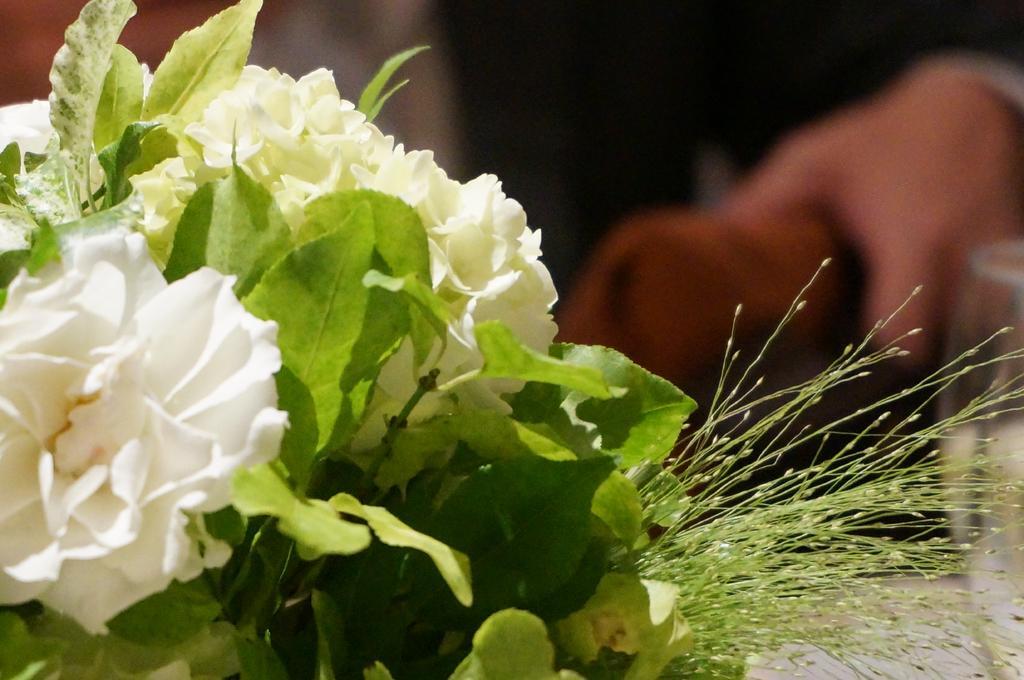How would you summarize this image in a sentence or two? In this image, we can see some leaves and flowers. In the background, image is blurred. 